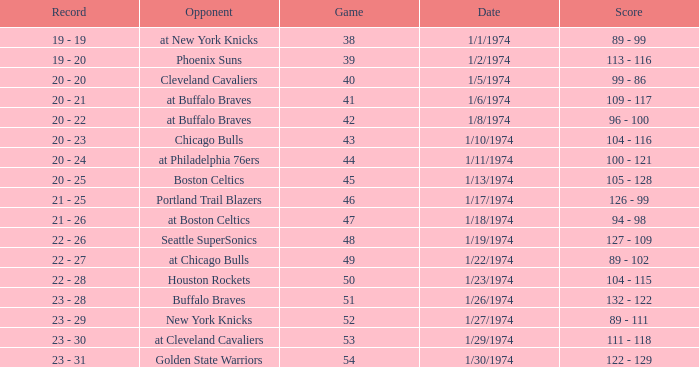What was the record after game 51 on 1/27/1974? 23 - 29. 